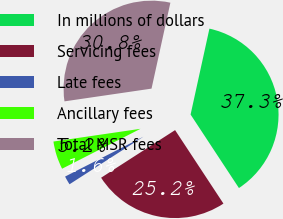Convert chart. <chart><loc_0><loc_0><loc_500><loc_500><pie_chart><fcel>In millions of dollars<fcel>Servicing fees<fcel>Late fees<fcel>Ancillary fees<fcel>Total MSR fees<nl><fcel>37.3%<fcel>25.16%<fcel>1.61%<fcel>5.18%<fcel>30.75%<nl></chart> 